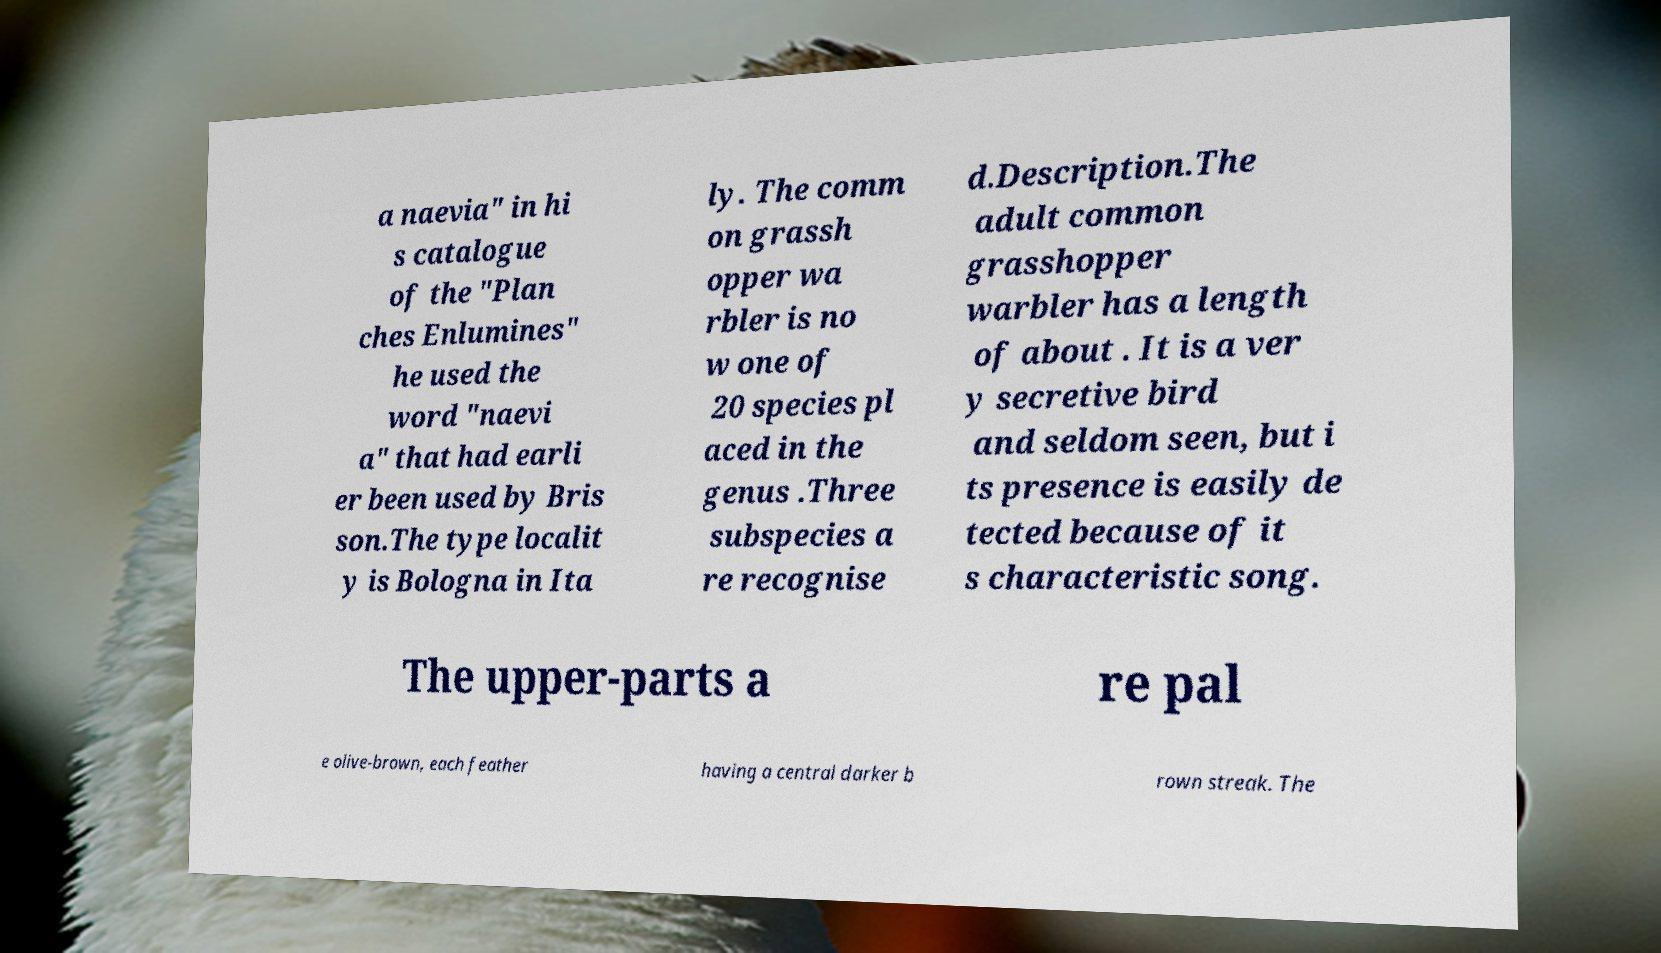I need the written content from this picture converted into text. Can you do that? a naevia" in hi s catalogue of the "Plan ches Enlumines" he used the word "naevi a" that had earli er been used by Bris son.The type localit y is Bologna in Ita ly. The comm on grassh opper wa rbler is no w one of 20 species pl aced in the genus .Three subspecies a re recognise d.Description.The adult common grasshopper warbler has a length of about . It is a ver y secretive bird and seldom seen, but i ts presence is easily de tected because of it s characteristic song. The upper-parts a re pal e olive-brown, each feather having a central darker b rown streak. The 